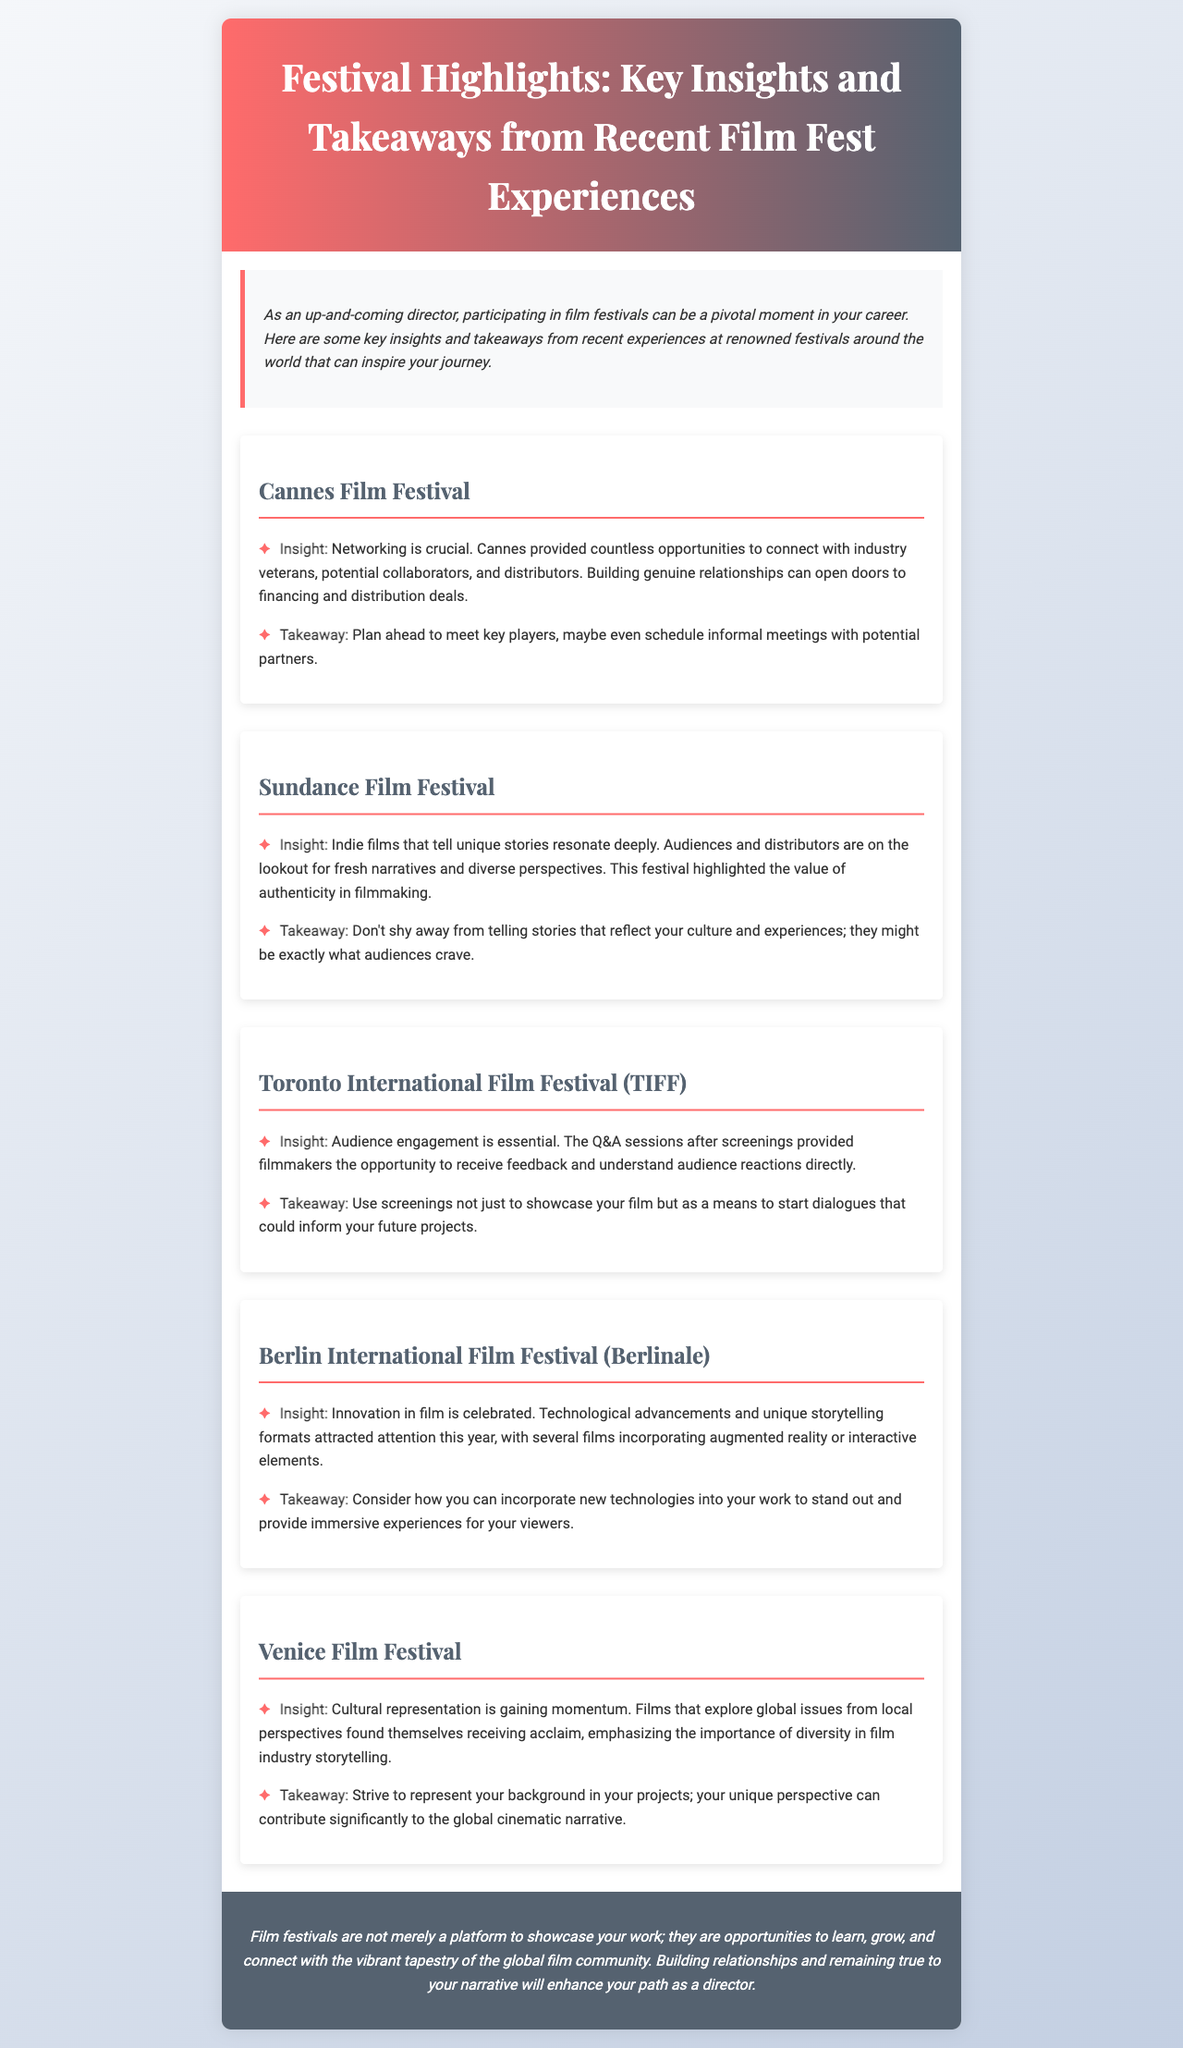What is the title of the newsletter? The title of the newsletter is highlighted prominently at the top of the document, reflecting its main theme.
Answer: Festival Highlights: Key Insights and Takeaways from Recent Film Fest Experiences Which festival emphasizes networking as crucial? The document states specific insights related to each festival, with Cannes being noted for its networking opportunities.
Answer: Cannes Film Festival What is the unique aspect highlighted about Sundance Film Festival? The document mentions that Sundance focuses on indie films that tell unique stories, which resonates with audiences.
Answer: Unique stories How many festivals are discussed in the document? The newsletter outlines insights from five different film festivals, indicating the breadth of coverage.
Answer: Five What is a key takeaway from the Berlin International Film Festival? The takeaway emphasizes incorporating new technologies to stand out, which is noted as an important trend in filmmaking this year.
Answer: Incorporate new technologies What does the newsletter suggest about cultural representation at the Venice Film Festival? The document notes that cultural representation is gaining momentum, highlighting its importance in storytelling.
Answer: Gaining momentum How are audience engagement opportunities described at TIFF? The document highlights that audience engagement is essential through Q&A sessions after screenings.
Answer: Q&A sessions Which festival is known for its emphasis on authenticity in filmmaking? The document explicitly states that Sundance highlighted the value of authenticity in filmmaking.
Answer: Sundance Film Festival 